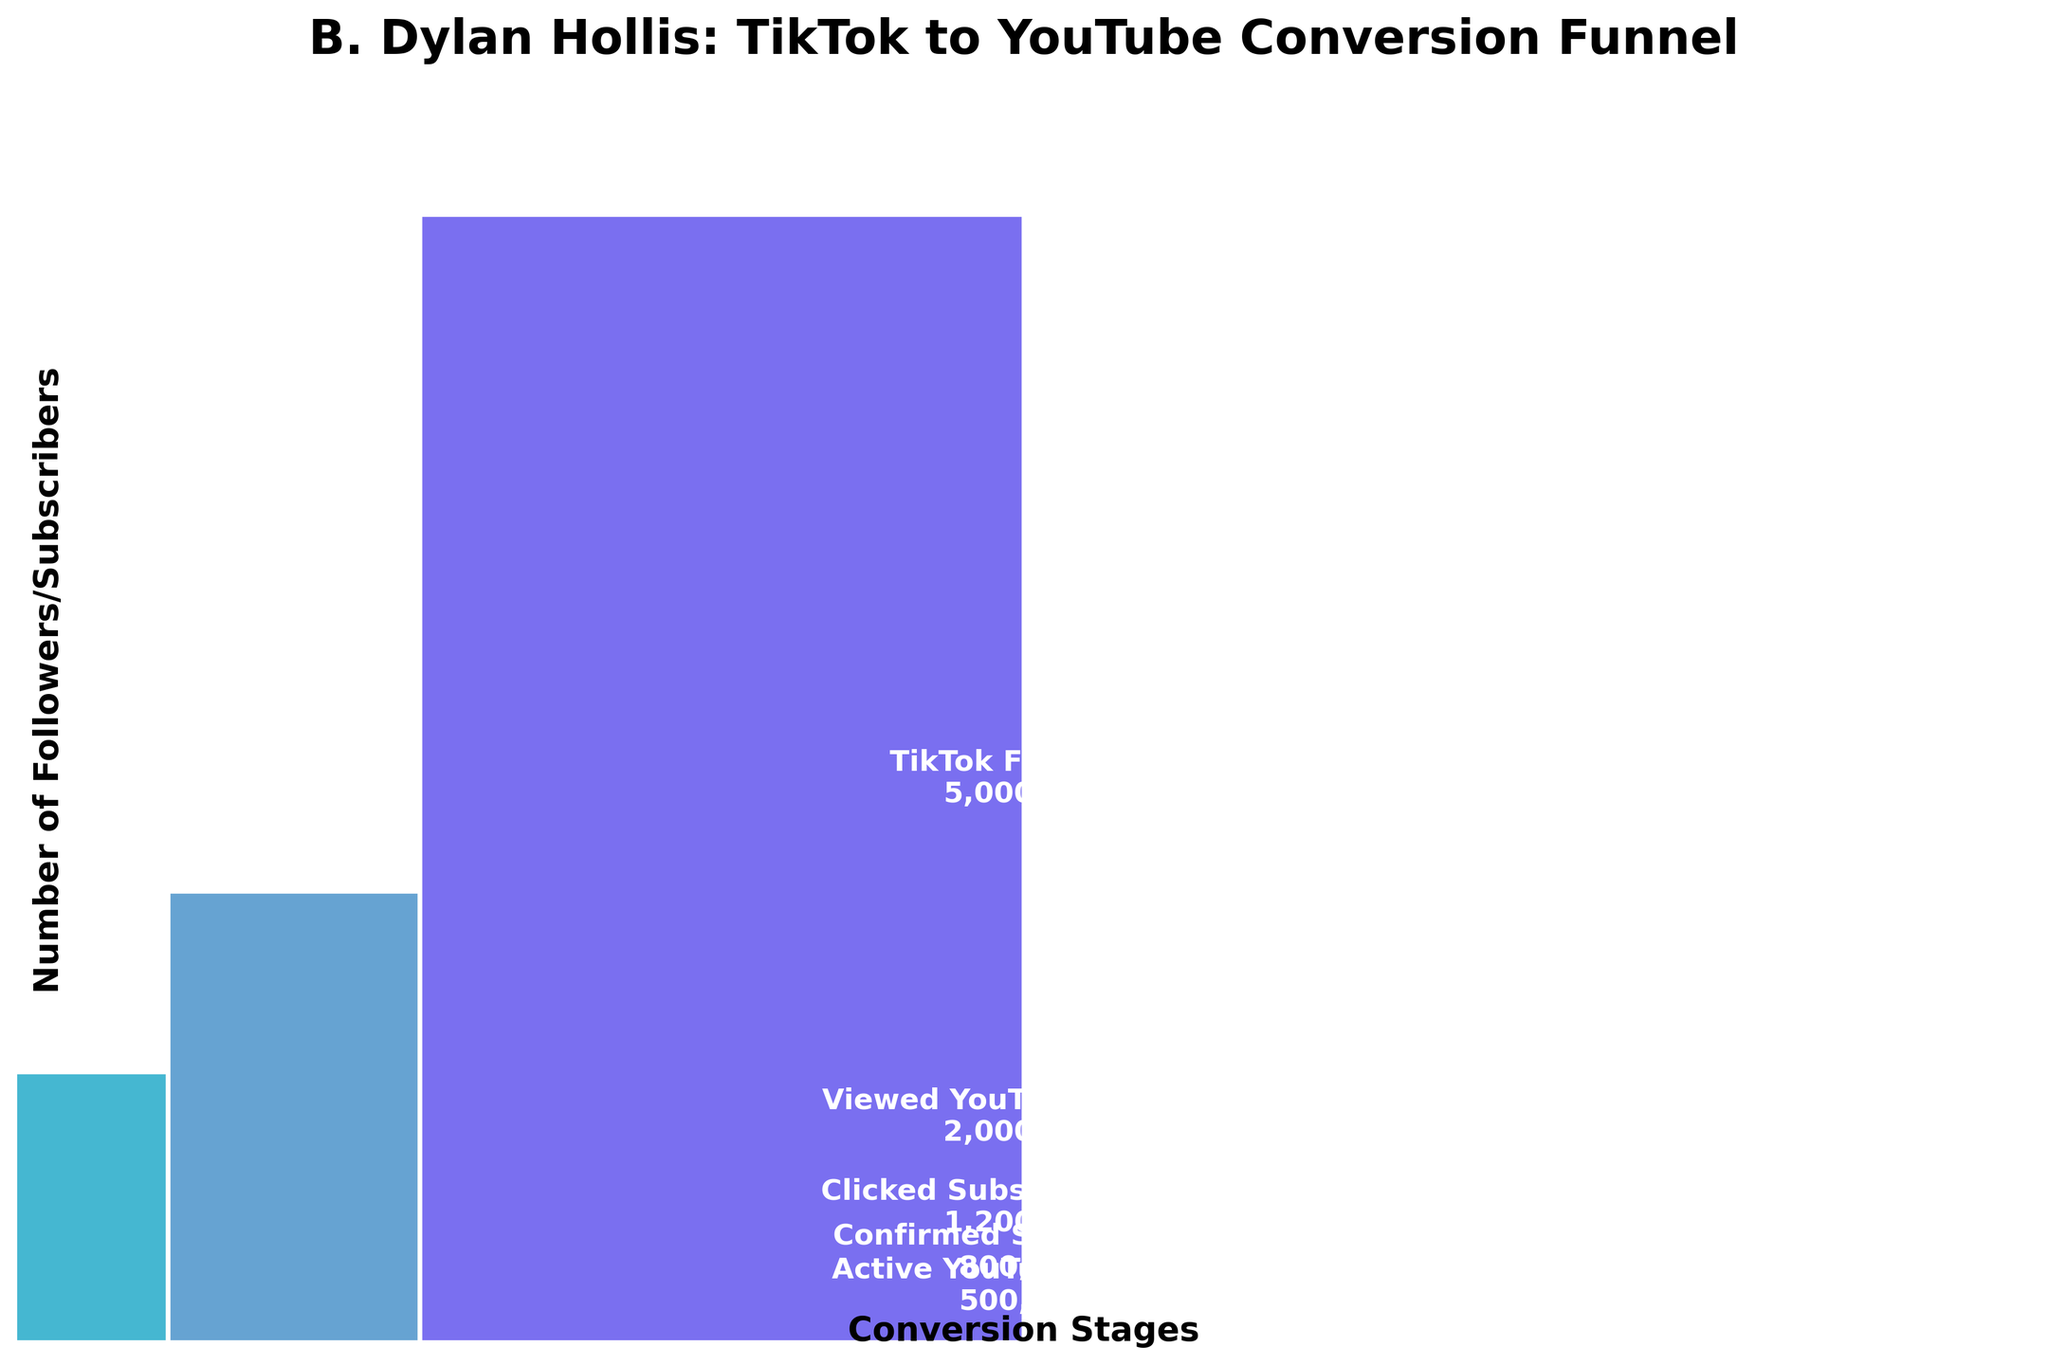How many TikTok followers are there at the top stage of the funnel? The figure shows stages of conversion with an initial count. "TikTok Followers" is the first stage with a count of 5,000,000.
Answer: 5,000,000 What's the title of the funnel chart? The title is displayed at the top of the chart.
Answer: B. Dylan Hollis: TikTok to YouTube Conversion Funnel How many followers viewed B. Dylan Hollis's YouTube channel? From the figure, the second stage "Viewed YouTube Channel" shows a count of 2,000,000.
Answer: 2,000,000 What's the difference between the number of TikTok followers and those who confirmed their YouTube subscription? Calculate the difference between "TikTok Followers" (5,000,000) and "Confirmed Subscription" (800,000).
Answer: 4,200,000 What stage has the smallest number of followers? Compare the counts of all stages; the lowest counting stage "Active YouTube Viewers" with 500,000.
Answer: Active YouTube Viewers Which stages show more than 1,000,000 followers? Identify stages with counts above 1,000,000: "TikTok Followers" (5,000,000), "Viewed YouTube Channel" (2,000,000), and "Clicked Subscribe Button" (1,200,000).
Answer: TikTok Followers, Viewed YouTube Channel, Clicked Subscribe Button What percentage of viewers clicked the subscribe button after viewing the YouTube channel? Calculate the percentage: (Clicked Subscribe Button / Viewed YouTube Channel) * 100 = (1,200,000 / 2,000,000) * 100.
Answer: 60% What color represents the "Confirmed Subscription" stage in the chart? Each stage has a different color. "Confirmed Subscription" is represented by light blue.
Answer: Light blue What is the average number of followers across all stages? Sum counts of all stages and divide by the number of stages: (5,000,000 + 2,000,000 + 1,200,000 + 800,000 + 500,000) / 5.
Answer: 1,900,000 At which stages do followers lose the most and least numbers successively? The biggest drop is from "TikTok Followers" to "Viewed YouTube Channel" (3,000,000), and the smallest drop is from "Confirmed Subscription" to "Active YouTube Viewers" (300,000).
Answer: Most: TikTok Followers to Viewed YouTube Channel; Least: Confirmed Subscription to Active YouTube Viewers 